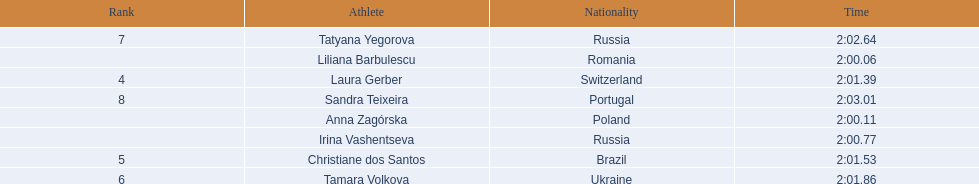What athletes are in the top five for the women's 800 metres? Liliana Barbulescu, Anna Zagórska, Irina Vashentseva, Laura Gerber, Christiane dos Santos. Which athletes are in the top 3? Liliana Barbulescu, Anna Zagórska, Irina Vashentseva. Who is the second place runner in the women's 800 metres? Anna Zagórska. What is the second place runner's time? 2:00.11. 